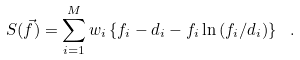<formula> <loc_0><loc_0><loc_500><loc_500>S ( \vec { f } ) = \sum _ { i = 1 } ^ { M } w _ { i } \left \{ f _ { i } - d _ { i } - f _ { i } \ln { ( f _ { i } / d _ { i } ) } \right \} \ .</formula> 